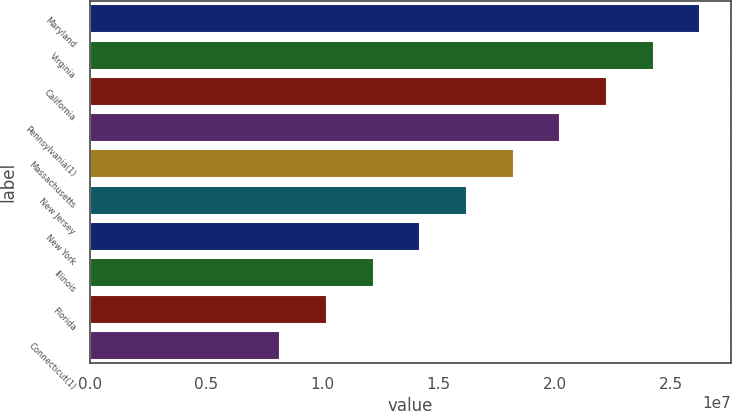<chart> <loc_0><loc_0><loc_500><loc_500><bar_chart><fcel>Maryland<fcel>Virginia<fcel>California<fcel>Pennsylvania(1)<fcel>Massachusetts<fcel>New Jersey<fcel>New York<fcel>Illinois<fcel>Florida<fcel>Connecticut(1)<nl><fcel>2.62687e+07<fcel>2.42598e+07<fcel>2.22509e+07<fcel>2.0242e+07<fcel>1.82331e+07<fcel>1.62242e+07<fcel>1.42153e+07<fcel>1.22064e+07<fcel>1.01975e+07<fcel>8.1886e+06<nl></chart> 